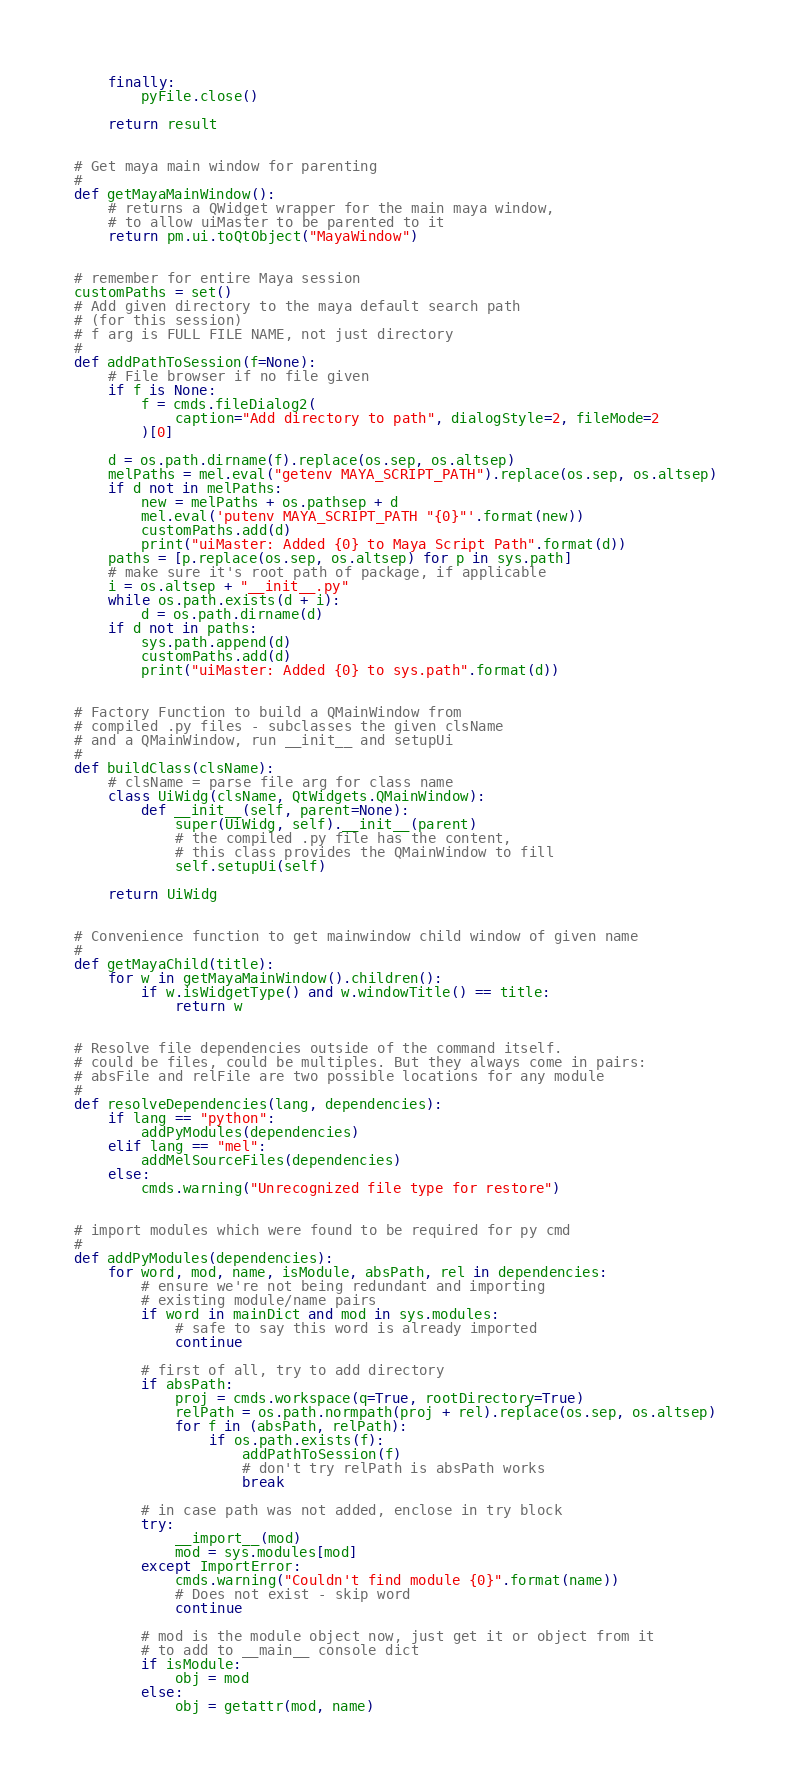<code> <loc_0><loc_0><loc_500><loc_500><_Python_>    finally:
        pyFile.close()

    return result


# Get maya main window for parenting
#
def getMayaMainWindow():
    # returns a QWidget wrapper for the main maya window,
    # to allow uiMaster to be parented to it
    return pm.ui.toQtObject("MayaWindow")


# remember for entire Maya session
customPaths = set()
# Add given directory to the maya default search path
# (for this session)
# f arg is FULL FILE NAME, not just directory
#
def addPathToSession(f=None):
    # File browser if no file given
    if f is None:
        f = cmds.fileDialog2(
            caption="Add directory to path", dialogStyle=2, fileMode=2
        )[0]

    d = os.path.dirname(f).replace(os.sep, os.altsep)
    melPaths = mel.eval("getenv MAYA_SCRIPT_PATH").replace(os.sep, os.altsep)
    if d not in melPaths:
        new = melPaths + os.pathsep + d
        mel.eval('putenv MAYA_SCRIPT_PATH "{0}"'.format(new))
        customPaths.add(d)
        print("uiMaster: Added {0} to Maya Script Path".format(d))
    paths = [p.replace(os.sep, os.altsep) for p in sys.path]
    # make sure it's root path of package, if applicable
    i = os.altsep + "__init__.py"
    while os.path.exists(d + i):
        d = os.path.dirname(d)
    if d not in paths:
        sys.path.append(d)
        customPaths.add(d)
        print("uiMaster: Added {0} to sys.path".format(d))


# Factory Function to build a QMainWindow from
# compiled .py files - subclasses the given clsName
# and a QMainWindow, run __init__ and setupUi
#
def buildClass(clsName):
    # clsName = parse file arg for class name
    class UiWidg(clsName, QtWidgets.QMainWindow):
        def __init__(self, parent=None):
            super(UiWidg, self).__init__(parent)
            # the compiled .py file has the content,
            # this class provides the QMainWindow to fill
            self.setupUi(self)

    return UiWidg


# Convenience function to get mainwindow child window of given name
#
def getMayaChild(title):
    for w in getMayaMainWindow().children():
        if w.isWidgetType() and w.windowTitle() == title:
            return w


# Resolve file dependencies outside of the command itself.
# could be files, could be multiples. But they always come in pairs:
# absFile and relFile are two possible locations for any module
#
def resolveDependencies(lang, dependencies):
    if lang == "python":
        addPyModules(dependencies)
    elif lang == "mel":
        addMelSourceFiles(dependencies)
    else:
        cmds.warning("Unrecognized file type for restore")


# import modules which were found to be required for py cmd
#
def addPyModules(dependencies):
    for word, mod, name, isModule, absPath, rel in dependencies:
        # ensure we're not being redundant and importing
        # existing module/name pairs
        if word in mainDict and mod in sys.modules:
            # safe to say this word is already imported
            continue

        # first of all, try to add directory
        if absPath:
            proj = cmds.workspace(q=True, rootDirectory=True)
            relPath = os.path.normpath(proj + rel).replace(os.sep, os.altsep)
            for f in (absPath, relPath):
                if os.path.exists(f):
                    addPathToSession(f)
                    # don't try relPath is absPath works
                    break

        # in case path was not added, enclose in try block
        try:
            __import__(mod)
            mod = sys.modules[mod]
        except ImportError:
            cmds.warning("Couldn't find module {0}".format(name))
            # Does not exist - skip word
            continue

        # mod is the module object now, just get it or object from it
        # to add to __main__ console dict
        if isModule:
            obj = mod
        else:
            obj = getattr(mod, name)</code> 